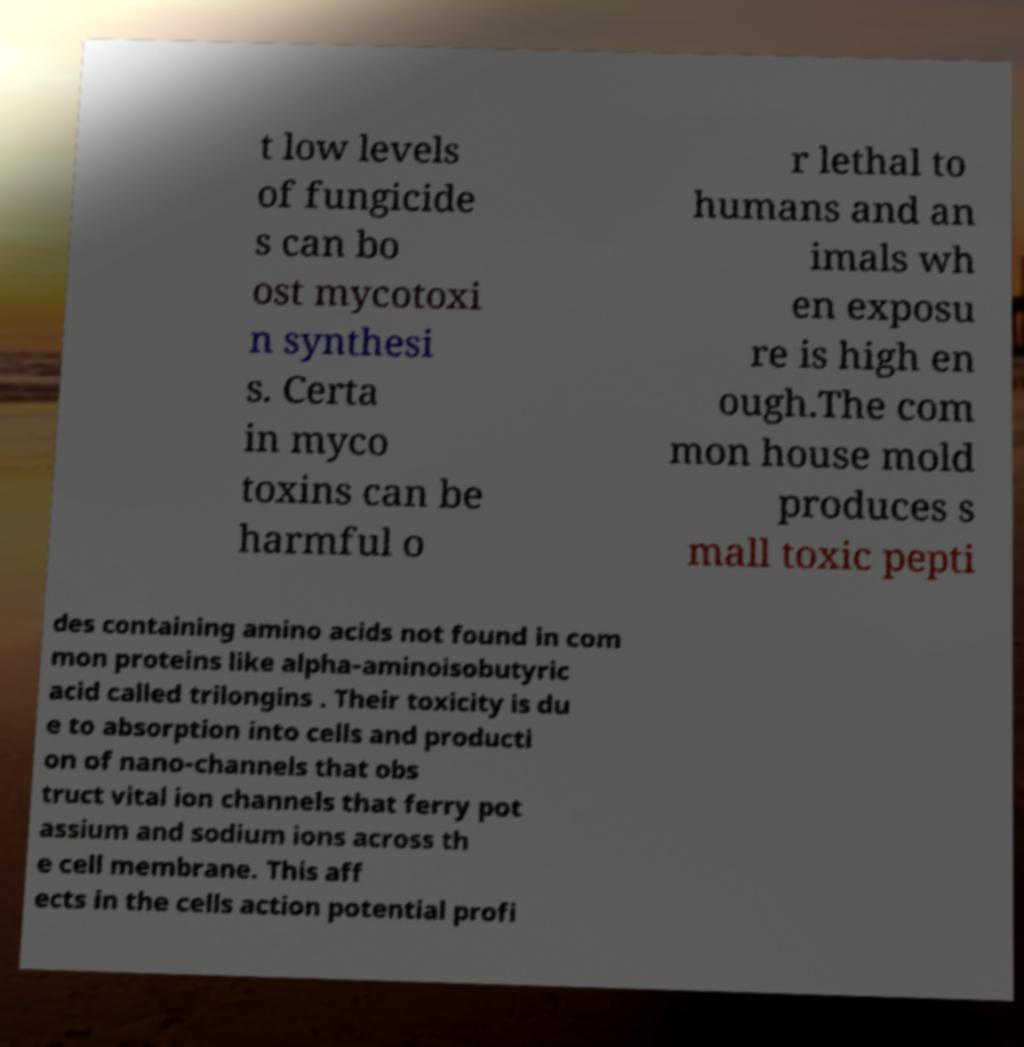Can you read and provide the text displayed in the image?This photo seems to have some interesting text. Can you extract and type it out for me? t low levels of fungicide s can bo ost mycotoxi n synthesi s. Certa in myco toxins can be harmful o r lethal to humans and an imals wh en exposu re is high en ough.The com mon house mold produces s mall toxic pepti des containing amino acids not found in com mon proteins like alpha-aminoisobutyric acid called trilongins . Their toxicity is du e to absorption into cells and producti on of nano-channels that obs truct vital ion channels that ferry pot assium and sodium ions across th e cell membrane. This aff ects in the cells action potential profi 